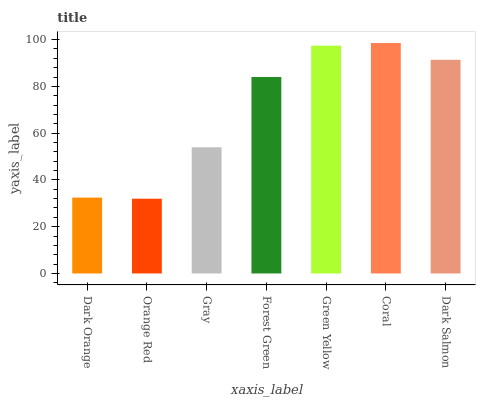Is Gray the minimum?
Answer yes or no. No. Is Gray the maximum?
Answer yes or no. No. Is Gray greater than Orange Red?
Answer yes or no. Yes. Is Orange Red less than Gray?
Answer yes or no. Yes. Is Orange Red greater than Gray?
Answer yes or no. No. Is Gray less than Orange Red?
Answer yes or no. No. Is Forest Green the high median?
Answer yes or no. Yes. Is Forest Green the low median?
Answer yes or no. Yes. Is Dark Salmon the high median?
Answer yes or no. No. Is Gray the low median?
Answer yes or no. No. 